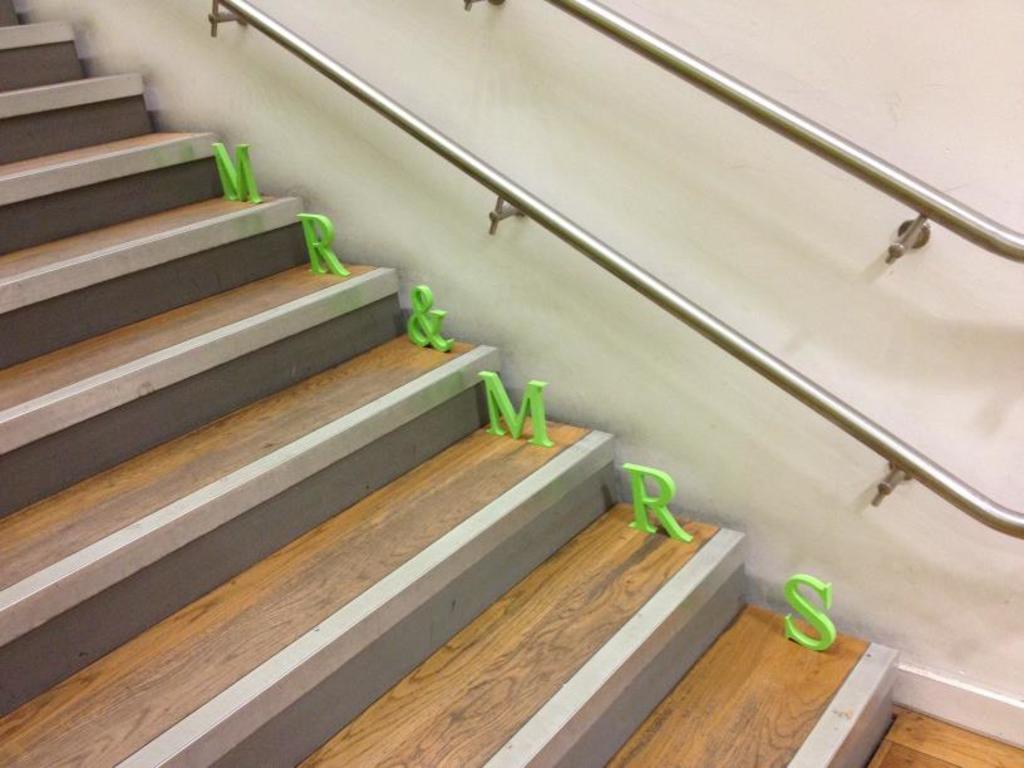Describe this image in one or two sentences. Here we can see staircase, alphabets, and rods. In the background there is a wall. 